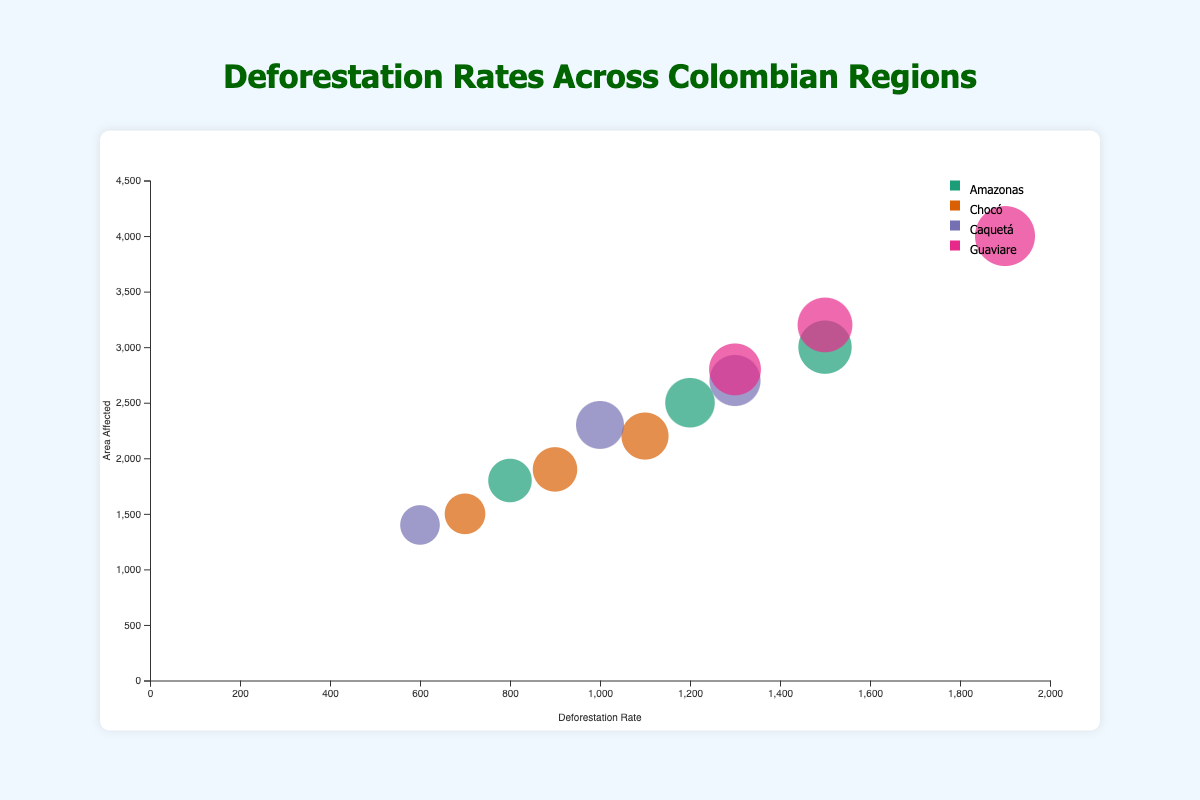Which region has the highest deforestation rate for the Cattle Ranching land use change? By checking the deforestation rate values for Cattle Ranching across all regions, we see that Guaviare has the highest rate.
Answer: Guaviare What is the approximate radius of the bubble representing Agriculture in Amazonas? The area affected by Agriculture in Amazonas is 2500. Using the radius scale, 2500 falls closer to the lower end of the range, indicating a medium-sized radius approximately.
Answer: Medium-sized How does the area affected by Illegal Mining in Amazonas compare to that of Coca Cultivation in Guaviare? Illegal Mining in Amazonas affects 1800 units of area, while Coca Cultivation in Guaviare affects 2800 units. Comparatively, the area affected by Coca Cultivation in Guaviare is larger.
Answer: Coca Cultivation in Guaviare is larger Which region exhibits the smallest bubble for Illegal Logging? Illegal Logging is only present in the Chocó region.
Answer: Chocó On average, how does the deforestation rate of Cattle Ranching compare to that of Agriculture across all regions? Sum the deforestation rates for Cattle Ranching and Agriculture across all regions and divide by the number of regions. For Cattle Ranching (1500+1100+1300+1900)/4 = 1450, and for Agriculture (1200+900+1000+1500)/4 = 1150. Thus, Cattle Ranching has a higher average.
Answer: Cattle Ranching is higher What is the deforestation rate for Coca Cultivation in Caquetá compared to Amazonas's Agriculture? The deforestation rate for Coca Cultivation in Caquetá is 600, and for Agriculture in Amazonas, it’s 1200. Thus, Amazonas's Agriculture has a higher rate.
Answer: Amazonas's Agriculture is higher Which region and land use type combination shows the highest area affected? By comparing the "area affected" values across all regions and land use types, the highest is Cattle Ranching in Guaviare with 4000.
Answer: Cattle Ranching in Guaviare What is the difference in the deforestation rate between the highest and lowest regions for agriculture? The highest deforestation rate for Agriculture is in Guaviare (1500), and the lowest is in Chocó (900). The difference is 1500 - 900 = 600.
Answer: 600 How many regions have a higher deforestation rate for Agriculture than for Cattle Ranching? By comparing the deforestation rates for Agriculture and Cattle Ranching within each region, none of the regions have a higher rate for Agriculture than Cattle Ranching.
Answer: 0 What is the combined area affected by Illegal activities (Illegal Mining and Illegal Logging) across all regions? Sum the areas affected by Illegal Mining in Amazonas (1800) and Chocó (700). The combined area is 1800 + 700 = 2500.
Answer: 2500 